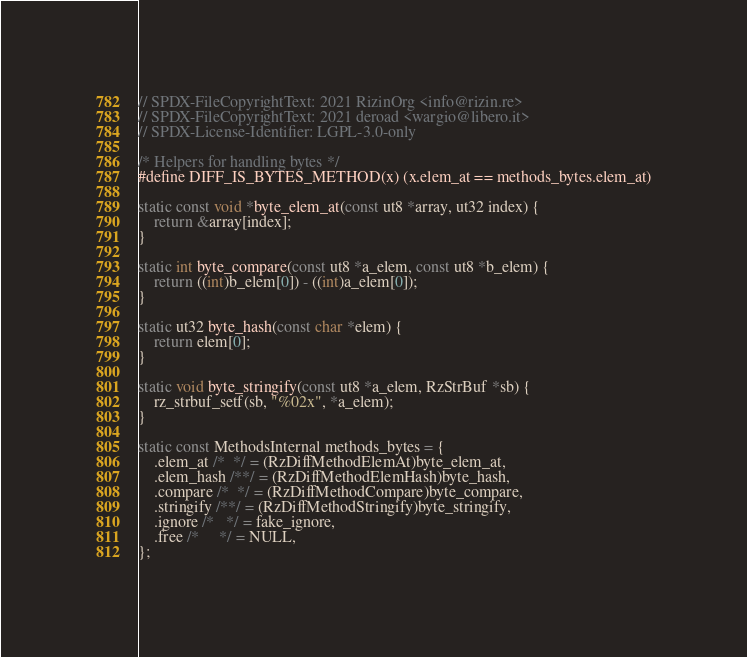Convert code to text. <code><loc_0><loc_0><loc_500><loc_500><_C_>// SPDX-FileCopyrightText: 2021 RizinOrg <info@rizin.re>
// SPDX-FileCopyrightText: 2021 deroad <wargio@libero.it>
// SPDX-License-Identifier: LGPL-3.0-only

/* Helpers for handling bytes */
#define DIFF_IS_BYTES_METHOD(x) (x.elem_at == methods_bytes.elem_at)

static const void *byte_elem_at(const ut8 *array, ut32 index) {
	return &array[index];
}

static int byte_compare(const ut8 *a_elem, const ut8 *b_elem) {
	return ((int)b_elem[0]) - ((int)a_elem[0]);
}

static ut32 byte_hash(const char *elem) {
	return elem[0];
}

static void byte_stringify(const ut8 *a_elem, RzStrBuf *sb) {
	rz_strbuf_setf(sb, "%02x", *a_elem);
}

static const MethodsInternal methods_bytes = {
	.elem_at /*  */ = (RzDiffMethodElemAt)byte_elem_at,
	.elem_hash /**/ = (RzDiffMethodElemHash)byte_hash,
	.compare /*  */ = (RzDiffMethodCompare)byte_compare,
	.stringify /**/ = (RzDiffMethodStringify)byte_stringify,
	.ignore /*   */ = fake_ignore,
	.free /*     */ = NULL,
};
</code> 